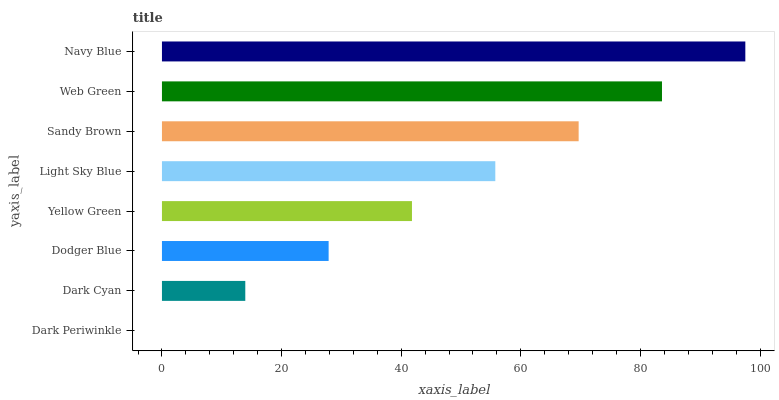Is Dark Periwinkle the minimum?
Answer yes or no. Yes. Is Navy Blue the maximum?
Answer yes or no. Yes. Is Dark Cyan the minimum?
Answer yes or no. No. Is Dark Cyan the maximum?
Answer yes or no. No. Is Dark Cyan greater than Dark Periwinkle?
Answer yes or no. Yes. Is Dark Periwinkle less than Dark Cyan?
Answer yes or no. Yes. Is Dark Periwinkle greater than Dark Cyan?
Answer yes or no. No. Is Dark Cyan less than Dark Periwinkle?
Answer yes or no. No. Is Light Sky Blue the high median?
Answer yes or no. Yes. Is Yellow Green the low median?
Answer yes or no. Yes. Is Navy Blue the high median?
Answer yes or no. No. Is Dark Periwinkle the low median?
Answer yes or no. No. 